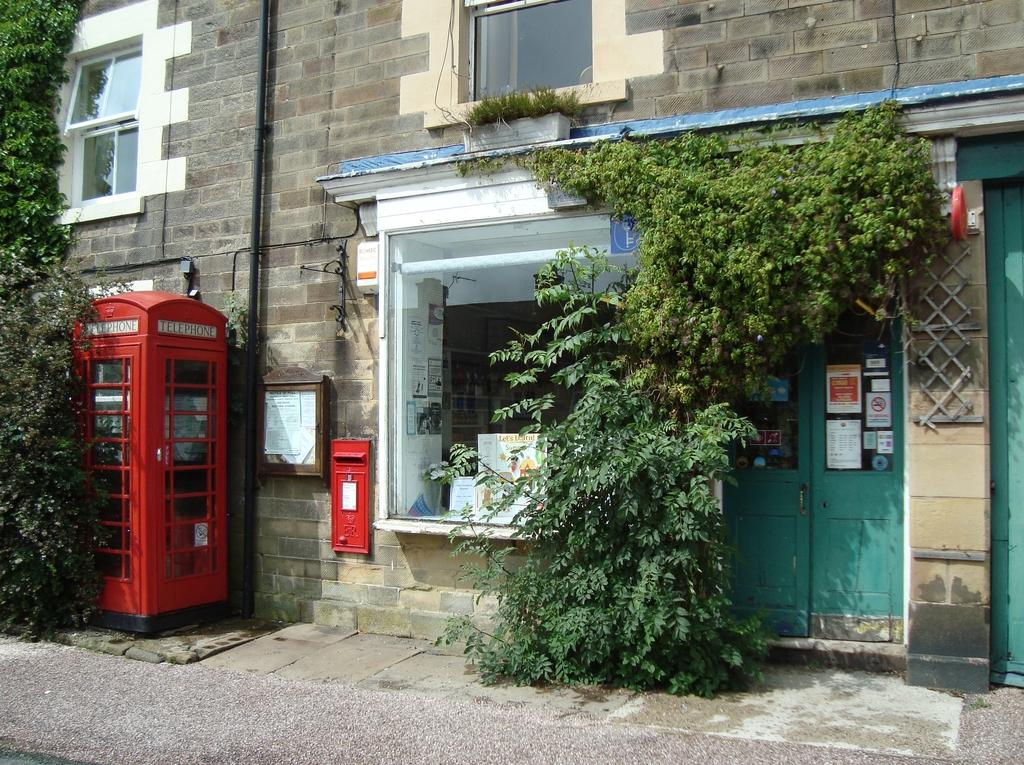What type of structure is visible in the image? There is a building in the image. What is a feature of the building that can be used for entering or exiting? There is a door in the image. What type of vegetation is present in the image? There is a plant in the image. What is a part of the building that allows light to enter and provides a view of the outside? There is a window glass in the image. What is a vertical object in the image that might be used for support or signage? There is a pole in the image. What type of dress is the pole wearing in the image? There is no dress present in the image, as the pole is an inanimate object and does not wear clothing. 